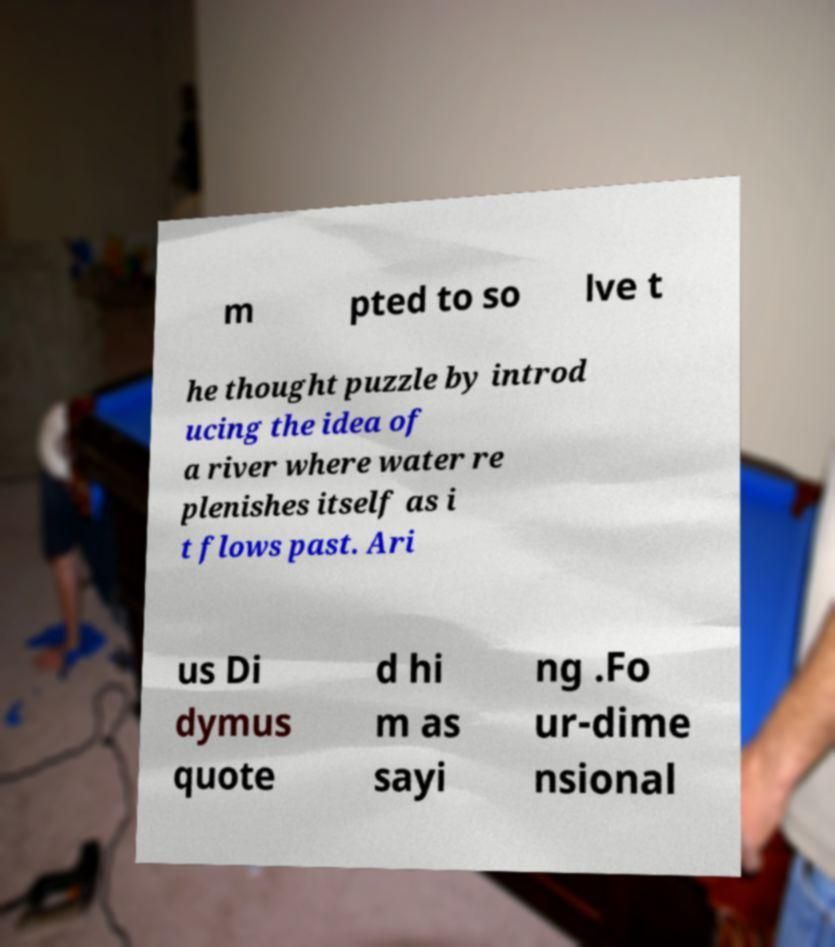Could you extract and type out the text from this image? m pted to so lve t he thought puzzle by introd ucing the idea of a river where water re plenishes itself as i t flows past. Ari us Di dymus quote d hi m as sayi ng .Fo ur-dime nsional 